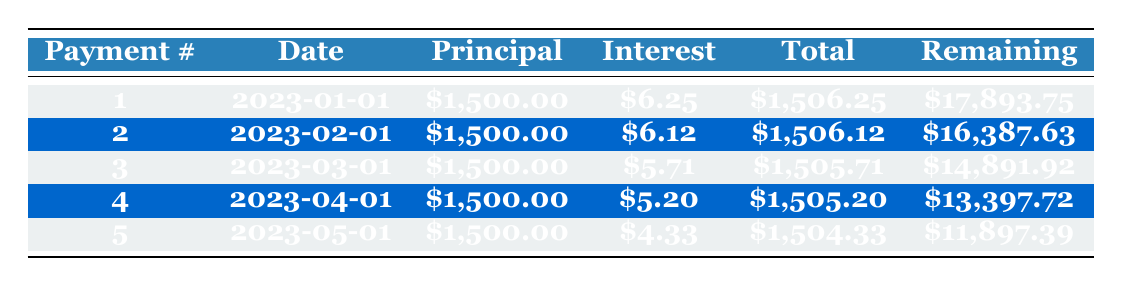What is the total payment for the first month? The first month's total payment is directly listed in the table under the "Total" column for Payment number 1, which is 1506.25.
Answer: 1506.25 What is the total remaining balance after the second payment? The remaining balance after the second payment is found in the "Remaining" column for Payment number 2, which shows 16387.63.
Answer: 16387.63 How much was the total interest paid in the first five months? To find the total interest paid in the first five months, we can sum the interest payments listed: 6.25 + 6.12 + 5.71 + 5.20 + 4.33 = 27.61.
Answer: 27.61 Is the principal payment the same for all five months? Yes, by checking the principal payment listed in each row, we see that it is consistently 1500 for all five months.
Answer: Yes What is the average total payment over the first five months? To calculate the average total payment, we sum the total payments for the five months: 1506.25 + 1506.12 + 1505.71 + 1505.20 + 1504.33 = 7527.61, and then divide by 5, resulting in 7527.61 / 5 = 1505.52.
Answer: 1505.52 What is the trend in remaining balances over the first five payments? By examining the remaining balance column, we see a consistent decrease, going from 17893.75 down to 11897.39, indicating that the balance is decreasing each month as payments are made.
Answer: The balance decreases each month How much interest payment is reduced from the first month to the fifth month? The interest payment in the first month is 6.25 and in the fifth month it's 4.33. To find the difference, we calculate 6.25 - 4.33 = 1.92, showing a reduction of 1.92 in the interest payment.
Answer: 1.92 What is the total amount paid after the third payment? To determine the total amount paid after three payments, we can sum the total payments for those three months: 1506.25 + 1506.12 + 1505.71 = 4518.08.
Answer: 4518.08 Is the initial deposit greater than any of the monthly payments? Yes, the initial deposit is 3000, which is greater than each monthly payment of 1500 listed in the table.
Answer: Yes 